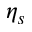<formula> <loc_0><loc_0><loc_500><loc_500>\eta _ { s }</formula> 